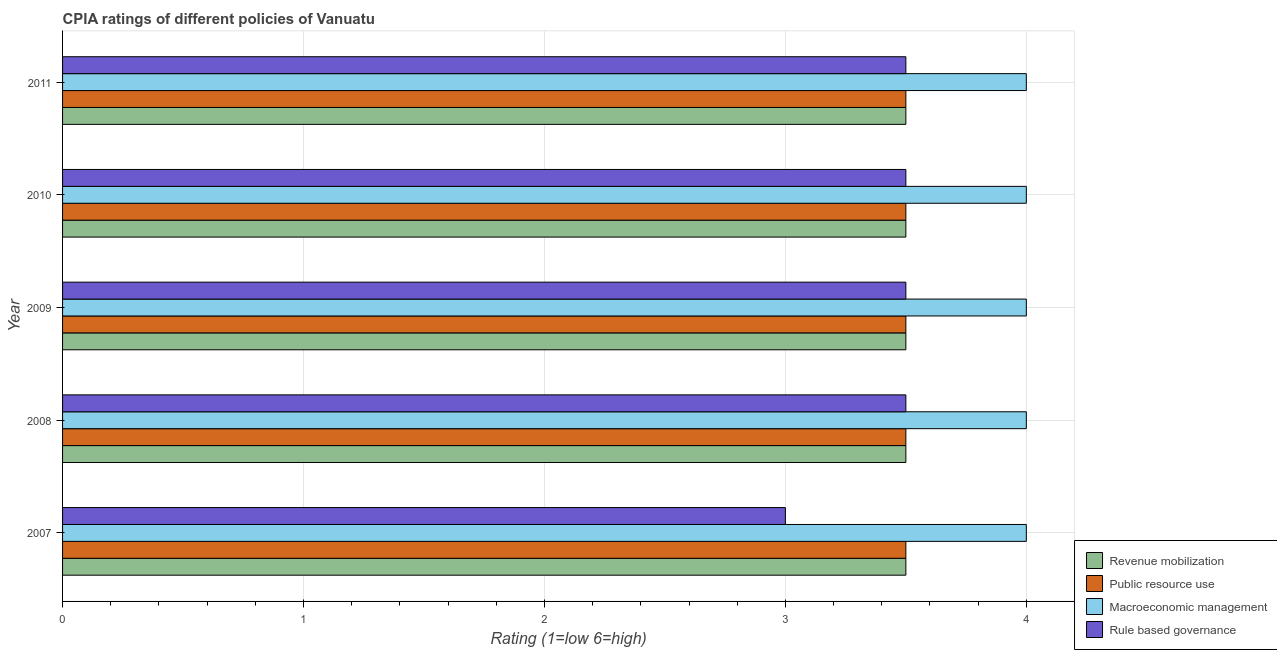How many different coloured bars are there?
Your response must be concise. 4. Are the number of bars per tick equal to the number of legend labels?
Give a very brief answer. Yes. Are the number of bars on each tick of the Y-axis equal?
Your response must be concise. Yes. How many bars are there on the 3rd tick from the top?
Offer a very short reply. 4. How many bars are there on the 3rd tick from the bottom?
Your answer should be compact. 4. What is the label of the 1st group of bars from the top?
Your answer should be very brief. 2011. What is the cpia rating of macroeconomic management in 2008?
Offer a very short reply. 4. Across all years, what is the maximum cpia rating of public resource use?
Provide a short and direct response. 3.5. Across all years, what is the minimum cpia rating of public resource use?
Your answer should be very brief. 3.5. In which year was the cpia rating of macroeconomic management maximum?
Keep it short and to the point. 2007. In which year was the cpia rating of public resource use minimum?
Ensure brevity in your answer.  2007. What is the total cpia rating of macroeconomic management in the graph?
Your response must be concise. 20. What is the difference between the cpia rating of revenue mobilization in 2007 and that in 2011?
Ensure brevity in your answer.  0. What is the difference between the cpia rating of macroeconomic management in 2007 and the cpia rating of rule based governance in 2008?
Keep it short and to the point. 0.5. In the year 2008, what is the difference between the cpia rating of revenue mobilization and cpia rating of macroeconomic management?
Offer a terse response. -0.5. In how many years, is the cpia rating of macroeconomic management greater than 3.2 ?
Provide a succinct answer. 5. What is the ratio of the cpia rating of rule based governance in 2009 to that in 2011?
Provide a short and direct response. 1. Is the difference between the cpia rating of public resource use in 2008 and 2009 greater than the difference between the cpia rating of revenue mobilization in 2008 and 2009?
Your answer should be very brief. No. What is the difference between the highest and the lowest cpia rating of rule based governance?
Provide a short and direct response. 0.5. In how many years, is the cpia rating of public resource use greater than the average cpia rating of public resource use taken over all years?
Offer a very short reply. 0. What does the 1st bar from the top in 2011 represents?
Your response must be concise. Rule based governance. What does the 2nd bar from the bottom in 2008 represents?
Keep it short and to the point. Public resource use. How many bars are there?
Keep it short and to the point. 20. How many years are there in the graph?
Make the answer very short. 5. Are the values on the major ticks of X-axis written in scientific E-notation?
Keep it short and to the point. No. Does the graph contain grids?
Offer a terse response. Yes. How many legend labels are there?
Your response must be concise. 4. What is the title of the graph?
Offer a terse response. CPIA ratings of different policies of Vanuatu. What is the label or title of the X-axis?
Provide a succinct answer. Rating (1=low 6=high). What is the Rating (1=low 6=high) in Revenue mobilization in 2007?
Your response must be concise. 3.5. What is the Rating (1=low 6=high) in Rule based governance in 2007?
Make the answer very short. 3. What is the Rating (1=low 6=high) of Revenue mobilization in 2008?
Keep it short and to the point. 3.5. What is the Rating (1=low 6=high) of Public resource use in 2008?
Give a very brief answer. 3.5. What is the Rating (1=low 6=high) in Rule based governance in 2008?
Provide a succinct answer. 3.5. What is the Rating (1=low 6=high) in Public resource use in 2009?
Provide a short and direct response. 3.5. What is the Rating (1=low 6=high) in Macroeconomic management in 2009?
Make the answer very short. 4. What is the Rating (1=low 6=high) of Macroeconomic management in 2010?
Your response must be concise. 4. What is the Rating (1=low 6=high) in Revenue mobilization in 2011?
Offer a very short reply. 3.5. What is the Rating (1=low 6=high) of Macroeconomic management in 2011?
Your response must be concise. 4. Across all years, what is the maximum Rating (1=low 6=high) of Revenue mobilization?
Ensure brevity in your answer.  3.5. Across all years, what is the maximum Rating (1=low 6=high) of Public resource use?
Keep it short and to the point. 3.5. Across all years, what is the maximum Rating (1=low 6=high) of Macroeconomic management?
Offer a very short reply. 4. Across all years, what is the minimum Rating (1=low 6=high) in Rule based governance?
Provide a succinct answer. 3. What is the total Rating (1=low 6=high) in Revenue mobilization in the graph?
Your answer should be very brief. 17.5. What is the difference between the Rating (1=low 6=high) of Public resource use in 2007 and that in 2008?
Your answer should be very brief. 0. What is the difference between the Rating (1=low 6=high) in Macroeconomic management in 2007 and that in 2008?
Make the answer very short. 0. What is the difference between the Rating (1=low 6=high) in Rule based governance in 2007 and that in 2008?
Your response must be concise. -0.5. What is the difference between the Rating (1=low 6=high) in Revenue mobilization in 2007 and that in 2010?
Keep it short and to the point. 0. What is the difference between the Rating (1=low 6=high) of Public resource use in 2007 and that in 2010?
Provide a succinct answer. 0. What is the difference between the Rating (1=low 6=high) of Macroeconomic management in 2007 and that in 2010?
Keep it short and to the point. 0. What is the difference between the Rating (1=low 6=high) in Rule based governance in 2007 and that in 2011?
Make the answer very short. -0.5. What is the difference between the Rating (1=low 6=high) in Revenue mobilization in 2008 and that in 2009?
Offer a terse response. 0. What is the difference between the Rating (1=low 6=high) in Rule based governance in 2008 and that in 2009?
Provide a succinct answer. 0. What is the difference between the Rating (1=low 6=high) of Public resource use in 2008 and that in 2010?
Provide a short and direct response. 0. What is the difference between the Rating (1=low 6=high) in Macroeconomic management in 2008 and that in 2010?
Provide a succinct answer. 0. What is the difference between the Rating (1=low 6=high) in Rule based governance in 2008 and that in 2010?
Your answer should be compact. 0. What is the difference between the Rating (1=low 6=high) in Revenue mobilization in 2008 and that in 2011?
Your response must be concise. 0. What is the difference between the Rating (1=low 6=high) in Public resource use in 2008 and that in 2011?
Provide a short and direct response. 0. What is the difference between the Rating (1=low 6=high) in Macroeconomic management in 2008 and that in 2011?
Your answer should be compact. 0. What is the difference between the Rating (1=low 6=high) in Revenue mobilization in 2009 and that in 2010?
Provide a succinct answer. 0. What is the difference between the Rating (1=low 6=high) in Public resource use in 2009 and that in 2010?
Give a very brief answer. 0. What is the difference between the Rating (1=low 6=high) in Macroeconomic management in 2009 and that in 2010?
Your answer should be compact. 0. What is the difference between the Rating (1=low 6=high) in Rule based governance in 2009 and that in 2010?
Your answer should be very brief. 0. What is the difference between the Rating (1=low 6=high) of Rule based governance in 2009 and that in 2011?
Your response must be concise. 0. What is the difference between the Rating (1=low 6=high) of Macroeconomic management in 2010 and that in 2011?
Your response must be concise. 0. What is the difference between the Rating (1=low 6=high) of Rule based governance in 2010 and that in 2011?
Your response must be concise. 0. What is the difference between the Rating (1=low 6=high) of Revenue mobilization in 2007 and the Rating (1=low 6=high) of Public resource use in 2008?
Give a very brief answer. 0. What is the difference between the Rating (1=low 6=high) in Revenue mobilization in 2007 and the Rating (1=low 6=high) in Rule based governance in 2008?
Keep it short and to the point. 0. What is the difference between the Rating (1=low 6=high) in Public resource use in 2007 and the Rating (1=low 6=high) in Rule based governance in 2008?
Make the answer very short. 0. What is the difference between the Rating (1=low 6=high) in Macroeconomic management in 2007 and the Rating (1=low 6=high) in Rule based governance in 2008?
Your answer should be compact. 0.5. What is the difference between the Rating (1=low 6=high) in Revenue mobilization in 2007 and the Rating (1=low 6=high) in Macroeconomic management in 2009?
Provide a short and direct response. -0.5. What is the difference between the Rating (1=low 6=high) of Public resource use in 2007 and the Rating (1=low 6=high) of Macroeconomic management in 2009?
Offer a very short reply. -0.5. What is the difference between the Rating (1=low 6=high) of Revenue mobilization in 2007 and the Rating (1=low 6=high) of Macroeconomic management in 2010?
Your response must be concise. -0.5. What is the difference between the Rating (1=low 6=high) in Revenue mobilization in 2007 and the Rating (1=low 6=high) in Rule based governance in 2010?
Your answer should be very brief. 0. What is the difference between the Rating (1=low 6=high) in Public resource use in 2007 and the Rating (1=low 6=high) in Rule based governance in 2010?
Your answer should be compact. 0. What is the difference between the Rating (1=low 6=high) of Revenue mobilization in 2007 and the Rating (1=low 6=high) of Public resource use in 2011?
Give a very brief answer. 0. What is the difference between the Rating (1=low 6=high) of Revenue mobilization in 2007 and the Rating (1=low 6=high) of Macroeconomic management in 2011?
Your answer should be very brief. -0.5. What is the difference between the Rating (1=low 6=high) in Revenue mobilization in 2007 and the Rating (1=low 6=high) in Rule based governance in 2011?
Offer a very short reply. 0. What is the difference between the Rating (1=low 6=high) of Public resource use in 2007 and the Rating (1=low 6=high) of Macroeconomic management in 2011?
Provide a succinct answer. -0.5. What is the difference between the Rating (1=low 6=high) in Public resource use in 2007 and the Rating (1=low 6=high) in Rule based governance in 2011?
Your response must be concise. 0. What is the difference between the Rating (1=low 6=high) of Macroeconomic management in 2007 and the Rating (1=low 6=high) of Rule based governance in 2011?
Offer a terse response. 0.5. What is the difference between the Rating (1=low 6=high) in Revenue mobilization in 2008 and the Rating (1=low 6=high) in Macroeconomic management in 2009?
Your answer should be compact. -0.5. What is the difference between the Rating (1=low 6=high) in Revenue mobilization in 2008 and the Rating (1=low 6=high) in Rule based governance in 2009?
Provide a short and direct response. 0. What is the difference between the Rating (1=low 6=high) of Public resource use in 2008 and the Rating (1=low 6=high) of Macroeconomic management in 2009?
Offer a terse response. -0.5. What is the difference between the Rating (1=low 6=high) in Macroeconomic management in 2008 and the Rating (1=low 6=high) in Rule based governance in 2009?
Ensure brevity in your answer.  0.5. What is the difference between the Rating (1=low 6=high) in Revenue mobilization in 2008 and the Rating (1=low 6=high) in Public resource use in 2010?
Your answer should be very brief. 0. What is the difference between the Rating (1=low 6=high) of Revenue mobilization in 2008 and the Rating (1=low 6=high) of Macroeconomic management in 2010?
Offer a terse response. -0.5. What is the difference between the Rating (1=low 6=high) of Public resource use in 2008 and the Rating (1=low 6=high) of Macroeconomic management in 2010?
Offer a terse response. -0.5. What is the difference between the Rating (1=low 6=high) in Revenue mobilization in 2008 and the Rating (1=low 6=high) in Public resource use in 2011?
Give a very brief answer. 0. What is the difference between the Rating (1=low 6=high) in Revenue mobilization in 2008 and the Rating (1=low 6=high) in Macroeconomic management in 2011?
Offer a terse response. -0.5. What is the difference between the Rating (1=low 6=high) in Revenue mobilization in 2008 and the Rating (1=low 6=high) in Rule based governance in 2011?
Offer a very short reply. 0. What is the difference between the Rating (1=low 6=high) of Public resource use in 2008 and the Rating (1=low 6=high) of Macroeconomic management in 2011?
Your response must be concise. -0.5. What is the difference between the Rating (1=low 6=high) in Revenue mobilization in 2009 and the Rating (1=low 6=high) in Macroeconomic management in 2010?
Your response must be concise. -0.5. What is the difference between the Rating (1=low 6=high) of Revenue mobilization in 2009 and the Rating (1=low 6=high) of Rule based governance in 2010?
Your answer should be compact. 0. What is the difference between the Rating (1=low 6=high) in Public resource use in 2009 and the Rating (1=low 6=high) in Macroeconomic management in 2010?
Your answer should be compact. -0.5. What is the difference between the Rating (1=low 6=high) of Revenue mobilization in 2009 and the Rating (1=low 6=high) of Public resource use in 2011?
Offer a very short reply. 0. What is the difference between the Rating (1=low 6=high) in Revenue mobilization in 2010 and the Rating (1=low 6=high) in Public resource use in 2011?
Your answer should be very brief. 0. What is the difference between the Rating (1=low 6=high) in Macroeconomic management in 2010 and the Rating (1=low 6=high) in Rule based governance in 2011?
Your answer should be very brief. 0.5. What is the average Rating (1=low 6=high) of Rule based governance per year?
Offer a terse response. 3.4. In the year 2007, what is the difference between the Rating (1=low 6=high) in Revenue mobilization and Rating (1=low 6=high) in Macroeconomic management?
Keep it short and to the point. -0.5. In the year 2007, what is the difference between the Rating (1=low 6=high) of Revenue mobilization and Rating (1=low 6=high) of Rule based governance?
Give a very brief answer. 0.5. In the year 2007, what is the difference between the Rating (1=low 6=high) in Public resource use and Rating (1=low 6=high) in Rule based governance?
Give a very brief answer. 0.5. In the year 2008, what is the difference between the Rating (1=low 6=high) of Revenue mobilization and Rating (1=low 6=high) of Public resource use?
Your answer should be compact. 0. In the year 2008, what is the difference between the Rating (1=low 6=high) in Public resource use and Rating (1=low 6=high) in Rule based governance?
Your answer should be very brief. 0. In the year 2008, what is the difference between the Rating (1=low 6=high) of Macroeconomic management and Rating (1=low 6=high) of Rule based governance?
Ensure brevity in your answer.  0.5. In the year 2009, what is the difference between the Rating (1=low 6=high) in Revenue mobilization and Rating (1=low 6=high) in Public resource use?
Your answer should be compact. 0. In the year 2009, what is the difference between the Rating (1=low 6=high) of Revenue mobilization and Rating (1=low 6=high) of Macroeconomic management?
Give a very brief answer. -0.5. In the year 2010, what is the difference between the Rating (1=low 6=high) of Revenue mobilization and Rating (1=low 6=high) of Public resource use?
Provide a succinct answer. 0. In the year 2010, what is the difference between the Rating (1=low 6=high) of Revenue mobilization and Rating (1=low 6=high) of Macroeconomic management?
Offer a very short reply. -0.5. In the year 2010, what is the difference between the Rating (1=low 6=high) of Public resource use and Rating (1=low 6=high) of Macroeconomic management?
Offer a terse response. -0.5. In the year 2011, what is the difference between the Rating (1=low 6=high) in Revenue mobilization and Rating (1=low 6=high) in Public resource use?
Offer a very short reply. 0. In the year 2011, what is the difference between the Rating (1=low 6=high) in Revenue mobilization and Rating (1=low 6=high) in Rule based governance?
Provide a short and direct response. 0. In the year 2011, what is the difference between the Rating (1=low 6=high) of Public resource use and Rating (1=low 6=high) of Macroeconomic management?
Your answer should be very brief. -0.5. In the year 2011, what is the difference between the Rating (1=low 6=high) of Macroeconomic management and Rating (1=low 6=high) of Rule based governance?
Keep it short and to the point. 0.5. What is the ratio of the Rating (1=low 6=high) in Revenue mobilization in 2007 to that in 2008?
Provide a short and direct response. 1. What is the ratio of the Rating (1=low 6=high) of Macroeconomic management in 2007 to that in 2008?
Keep it short and to the point. 1. What is the ratio of the Rating (1=low 6=high) in Public resource use in 2007 to that in 2009?
Ensure brevity in your answer.  1. What is the ratio of the Rating (1=low 6=high) of Rule based governance in 2007 to that in 2009?
Make the answer very short. 0.86. What is the ratio of the Rating (1=low 6=high) of Public resource use in 2007 to that in 2010?
Offer a very short reply. 1. What is the ratio of the Rating (1=low 6=high) of Public resource use in 2007 to that in 2011?
Offer a terse response. 1. What is the ratio of the Rating (1=low 6=high) of Revenue mobilization in 2008 to that in 2009?
Give a very brief answer. 1. What is the ratio of the Rating (1=low 6=high) in Macroeconomic management in 2008 to that in 2009?
Offer a terse response. 1. What is the ratio of the Rating (1=low 6=high) in Public resource use in 2008 to that in 2010?
Provide a short and direct response. 1. What is the ratio of the Rating (1=low 6=high) in Revenue mobilization in 2008 to that in 2011?
Your answer should be very brief. 1. What is the ratio of the Rating (1=low 6=high) in Macroeconomic management in 2008 to that in 2011?
Provide a succinct answer. 1. What is the ratio of the Rating (1=low 6=high) of Revenue mobilization in 2009 to that in 2010?
Keep it short and to the point. 1. What is the ratio of the Rating (1=low 6=high) of Public resource use in 2009 to that in 2010?
Your response must be concise. 1. What is the ratio of the Rating (1=low 6=high) in Rule based governance in 2009 to that in 2010?
Make the answer very short. 1. What is the ratio of the Rating (1=low 6=high) in Public resource use in 2009 to that in 2011?
Keep it short and to the point. 1. What is the ratio of the Rating (1=low 6=high) of Rule based governance in 2009 to that in 2011?
Your answer should be compact. 1. What is the ratio of the Rating (1=low 6=high) in Revenue mobilization in 2010 to that in 2011?
Keep it short and to the point. 1. What is the ratio of the Rating (1=low 6=high) in Macroeconomic management in 2010 to that in 2011?
Offer a terse response. 1. What is the difference between the highest and the second highest Rating (1=low 6=high) in Macroeconomic management?
Ensure brevity in your answer.  0. What is the difference between the highest and the lowest Rating (1=low 6=high) of Revenue mobilization?
Keep it short and to the point. 0. What is the difference between the highest and the lowest Rating (1=low 6=high) in Rule based governance?
Provide a succinct answer. 0.5. 